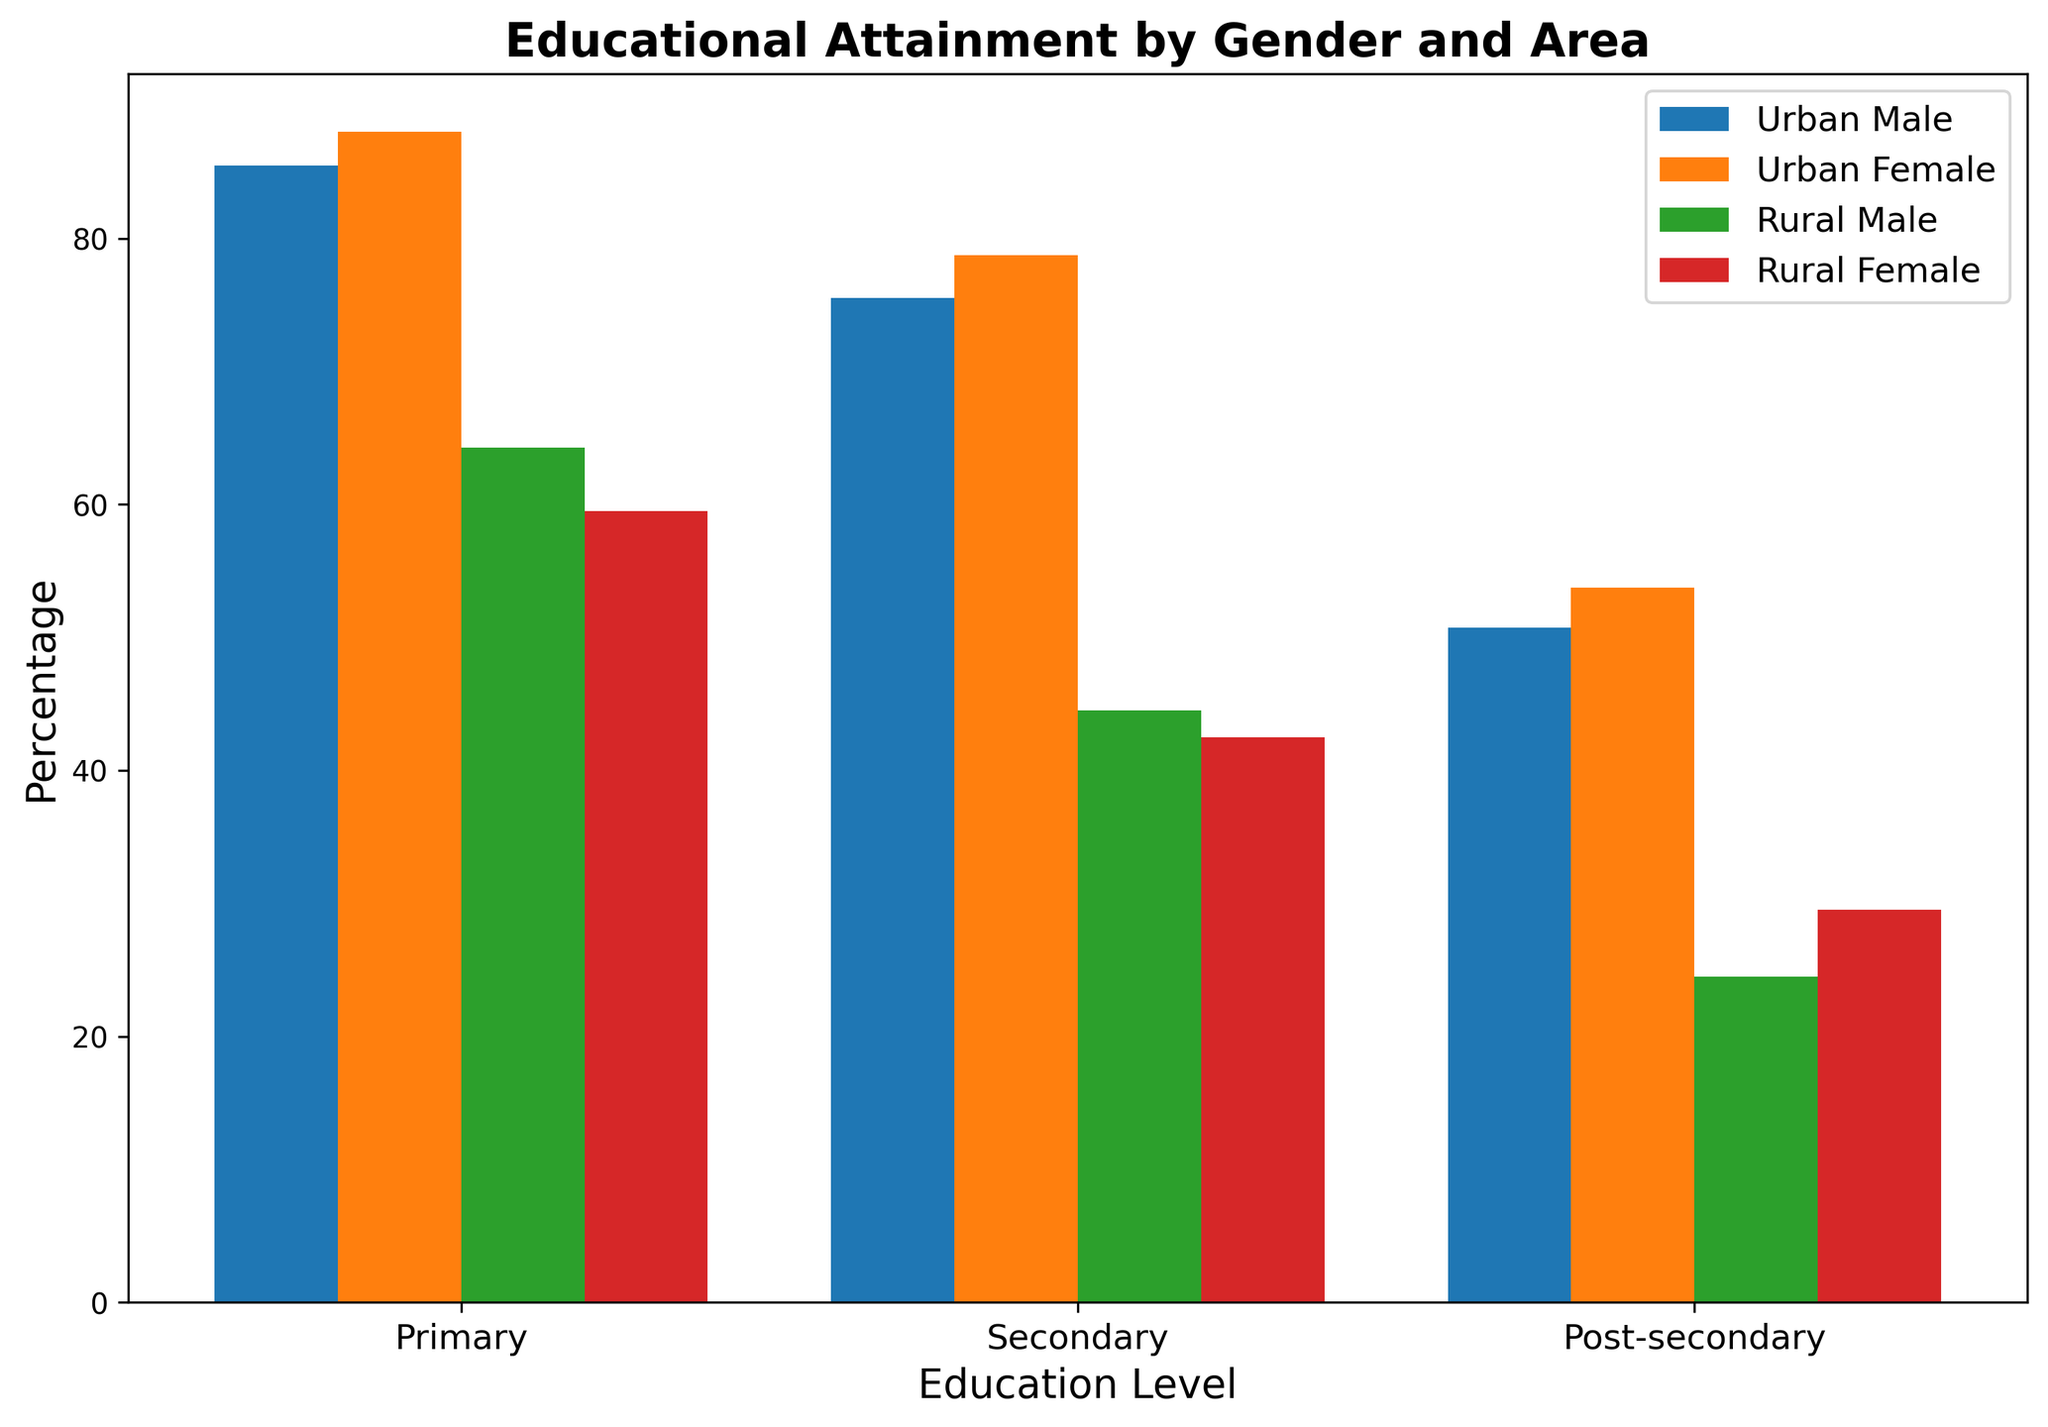What's the difference in primary education attainment between urban males and rural males? To find the difference, look at the height of the bars representing primary education for urban males and rural males. The urban male bar reaches 85%, and the rural male bar reaches 64%. Subtract the rural male percentage from the urban male percentage: 85% - 64% = 21%.
Answer: 21% Which group has the highest percentage in post-secondary education attainment? Look at the height of the bars representing post-secondary education for all groups. The urban female bar reaches the highest point at 55%.
Answer: Urban female What is the average secondary education attainment for rural females and urban females? Calculate the mean of the secondary education attainment percentages for rural females and urban females. The percentage for rural females is 43%, and for urban females, it is 80%. The average is (43% + 80%) / 2 = 61.5%.
Answer: 61.5% How does primary education attainment for urban females compare to rural females? Observe the height of the bars representing primary education for urban females and rural females. The urban female bar reaches 90%, and the rural female bar reaches 60%. Urban females have a higher primary education attainment by 30%.
Answer: Urban females have 30% higher primary education attainment Which group has the lowest attainment in secondary education? Identify the shortest bar representing secondary education attainment among all groups. The rural female bar reaches the lowest point at 38%.
Answer: Rural female What is the total post-secondary education attainment for urban males and rural males combined? Add the percentages for post-secondary education attainment of urban males and rural males. The urban male bar reaches 50%, and the rural male bar reaches 25%. The total is 50% + 25% = 75%.
Answer: 75% Compare the gender inequality in secondary education attainment within rural areas. Look at the difference in secondary education attainment percentages between rural males and rural females. Rural male bar reaches 45% and rural female bar reaches 43%. The difference is 45% - 43% = 2%.
Answer: 2% What percentage difference is there between urban females and rural females in post-secondary education? Find the percentage for post-secondary education attainment for both urban females and rural females and determine their difference. Urban female bar reaches 55%, rural female bar reaches 29%. The difference is 55% - 29% = 26%.
Answer: 26% How does the urban male's post-secondary education attainment compare to the rural male's in terms of times greater? Divide the urban male post-secondary attainment percentage by that of the rural male. Urban male post-secondary percentage is 50%, and rural male is 25%. So, 50% / 25% = 2 times.
Answer: 2 times 